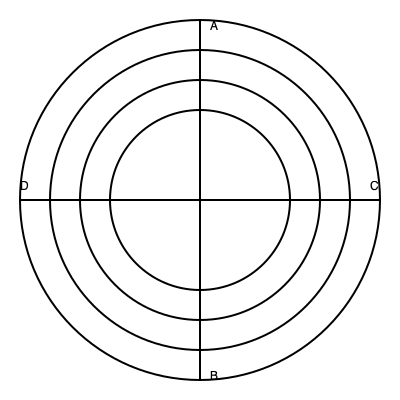In a theoretical faster-than-light engine, four interlocking gears (A, B, C, and D) are arranged as shown in the diagram. If gear A rotates clockwise at a speed of 1000 RPM, and each subsequent gear has 1.5 times the radius of the previous one, what will be the rotational speed and direction of gear D? To solve this problem, we need to follow these steps:

1. Understand the gear arrangement:
   - Gear A is the outermost gear
   - Each subsequent gear has 1.5 times the radius of the previous one

2. Calculate the relative sizes of the gears:
   - Gear A: radius = r
   - Gear B: radius = 1.5r
   - Gear C: radius = 1.5 * 1.5r = 2.25r
   - Gear D: radius = 1.5 * 2.25r = 3.375r

3. Determine the rotation direction of each gear:
   - Gear A: Clockwise
   - Gear B: Counterclockwise (opposite of A)
   - Gear C: Clockwise (opposite of B)
   - Gear D: Counterclockwise (opposite of C)

4. Calculate the speed of each gear:
   - The angular velocity (ω) of each gear is inversely proportional to its radius
   - ω₁r₁ = ω₂r₂ (where ω is angular velocity and r is radius)

   For Gear A to B:
   ω_A * r = ω_B * 1.5r
   1000 * r = ω_B * 1.5r
   ω_B = 1000 / 1.5 = 666.67 RPM

   For Gear B to C:
   666.67 * 1.5r = ω_C * 2.25r
   ω_C = (666.67 * 1.5) / 2.25 = 444.44 RPM

   For Gear C to D:
   444.44 * 2.25r = ω_D * 3.375r
   ω_D = (444.44 * 2.25) / 3.375 = 296.30 RPM

Therefore, Gear D will rotate counterclockwise at approximately 296.30 RPM.
Answer: 296.30 RPM counterclockwise 